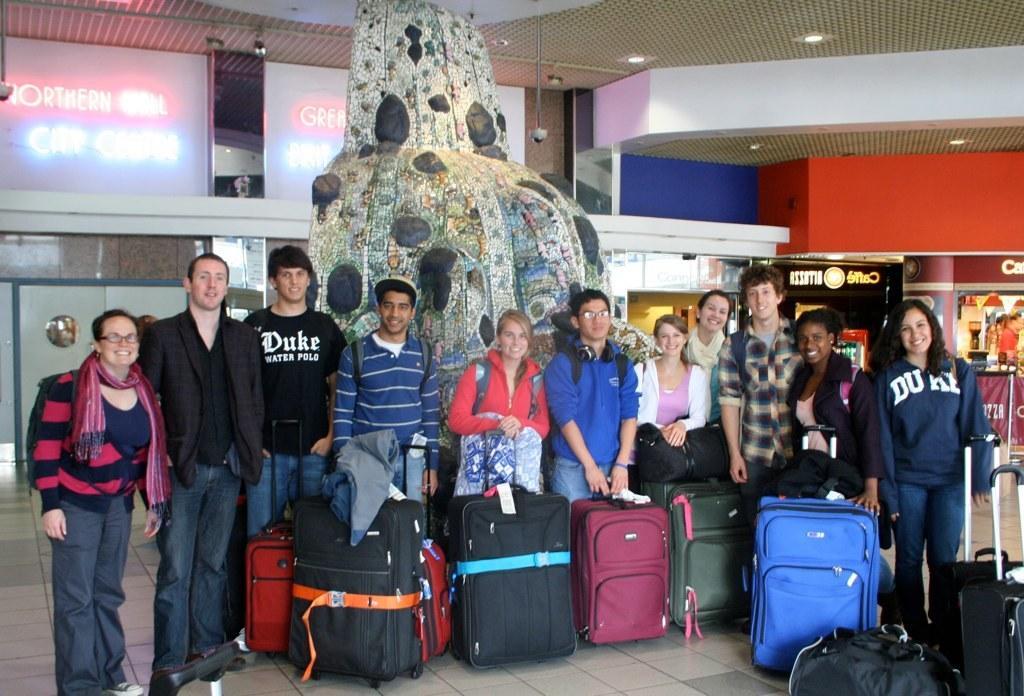Could you give a brief overview of what you see in this image? In the image we can see there are people who are standing with their suitcase and luggage. 